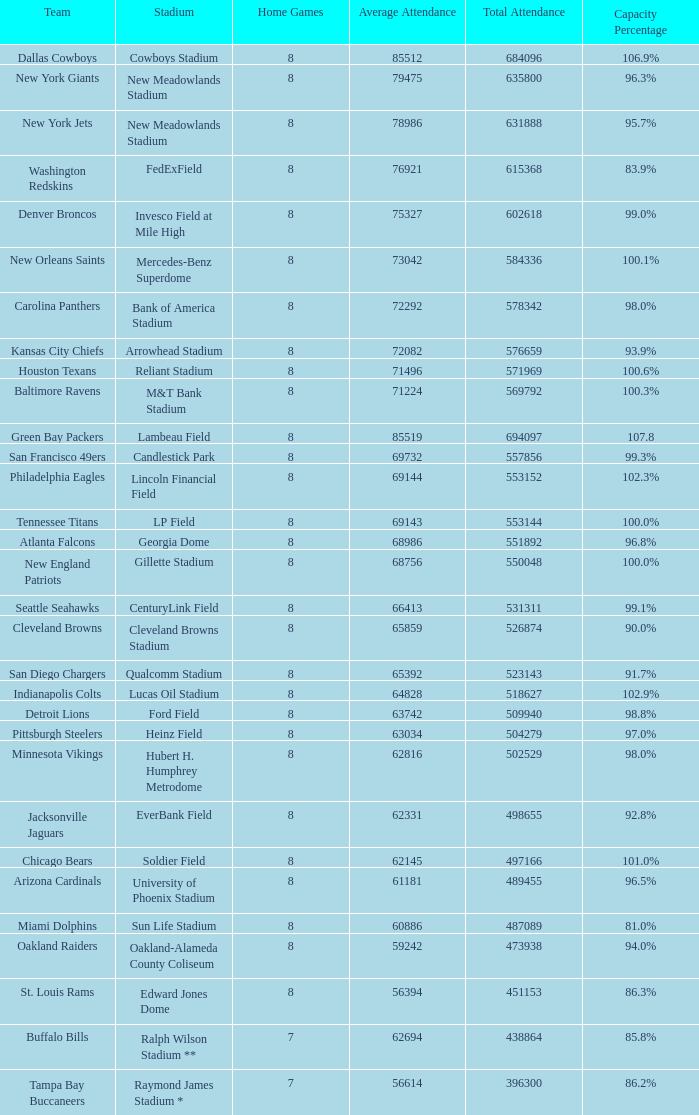What is the percentage of capacity when the total presence is 509940? 98.8%. 